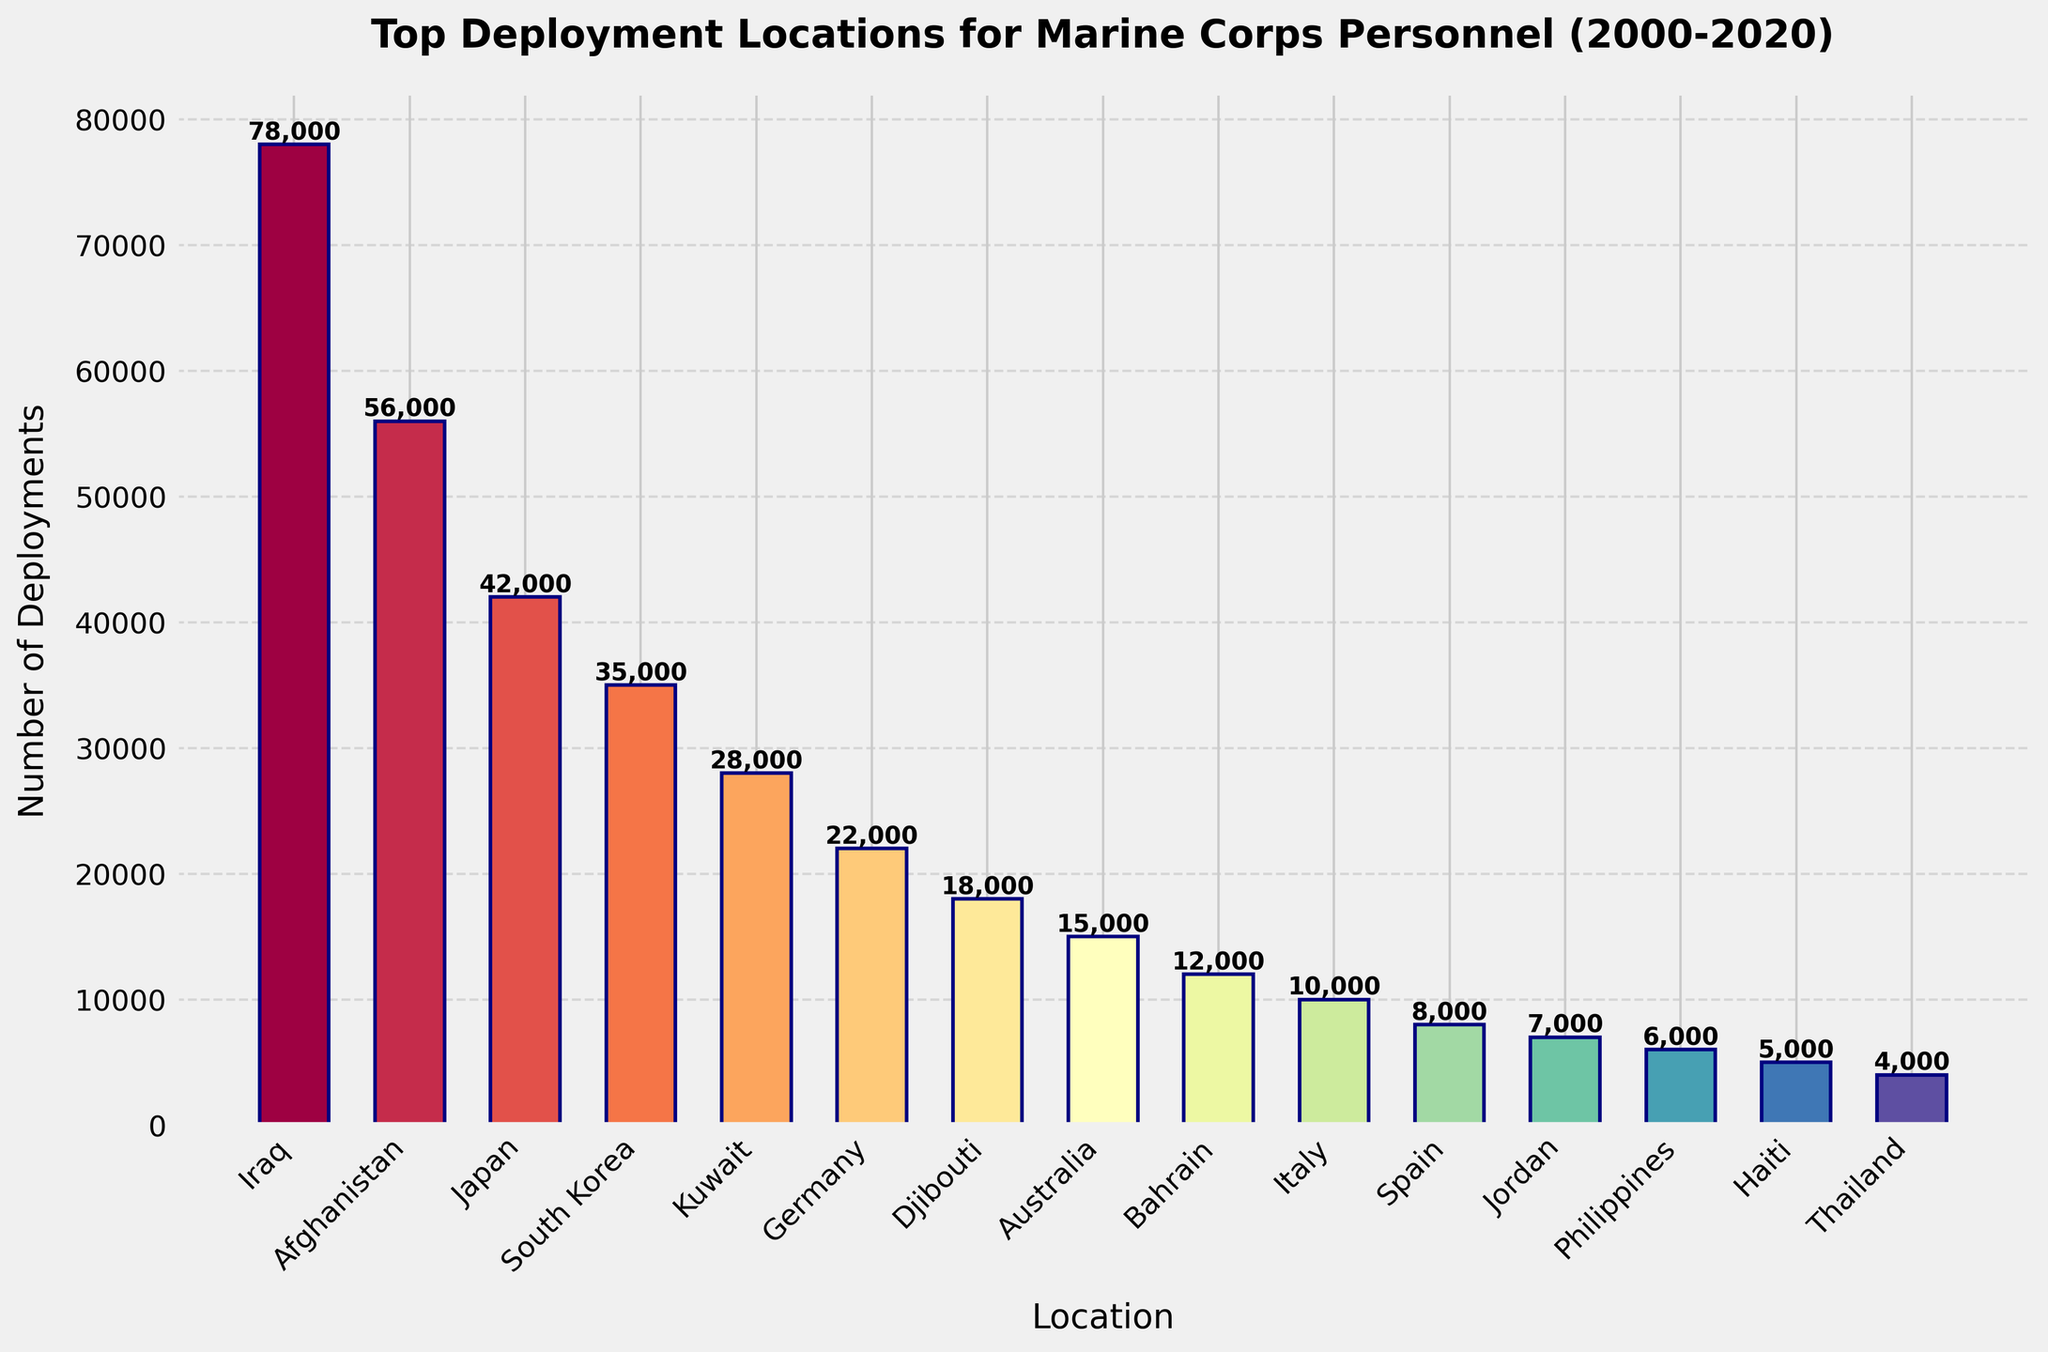What are the top three deployment locations for Marine Corps personnel between 2000-2020? To answer this, identify the three bars with the tallest heights in the bar chart. The locations corresponding to these bars are the top three deployment locations.
Answer: Iraq, Afghanistan, Japan What is the total number of deployments to Iraq and Afghanistan combined? Look at the deployment numbers for Iraq and Afghanistan and add them together. Iraq has 78,000 deployments and Afghanistan has 56,000 deployments: 78,000 + 56,000 = 134,000.
Answer: 134,000 How many more deployments were there to Iraq compared to Kuwait? Identify the deployment numbers for Iraq and Kuwait and find the difference. Iraq has 78,000 deployments and Kuwait has 28,000 deployments: 78,000 - 28,000 = 50,000.
Answer: 50,000 Which location has the least number of deployments, and how many? Find the bar with the shortest height in the bar chart, which represents the location with the fewest deployments. Read the number from the top of this bar.
Answer: Thailand, 4,000 What is the average number of deployments for the listed locations? Sum all the deployment numbers for the locations and divide by the number of locations (15 in total). The deployments sum to 308,000, so the average is 308,000 / 15.
Answer: 20,533 Is the number of deployments to Germany greater than the number to Djibouti? Compare the deployment numbers for Germany and Djibouti. Germany has 22,000 deployments, and Djibouti has 18,000. Since 22,000 is greater than 18,000, the answer is yes.
Answer: Yes How many locations have more than 30,000 deployments? Count the number of bars that have deployment numbers higher than 30,000. This includes Iraq (78,000), Afghanistan (56,000), Japan (42,000), and South Korea (35,000).
Answer: 4 By what visual attributes can you easily distinguish the deployment numbers of different locations? Describe how the bar chart visually represents differences, such as bar height, color, and position on the x-axis. In this chart, taller bars and variations in color are used.
Answer: Bar height, color 